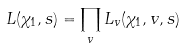<formula> <loc_0><loc_0><loc_500><loc_500>L ( \chi _ { 1 } , s ) = \prod _ { v } L _ { v } ( \chi _ { 1 } , v , s )</formula> 